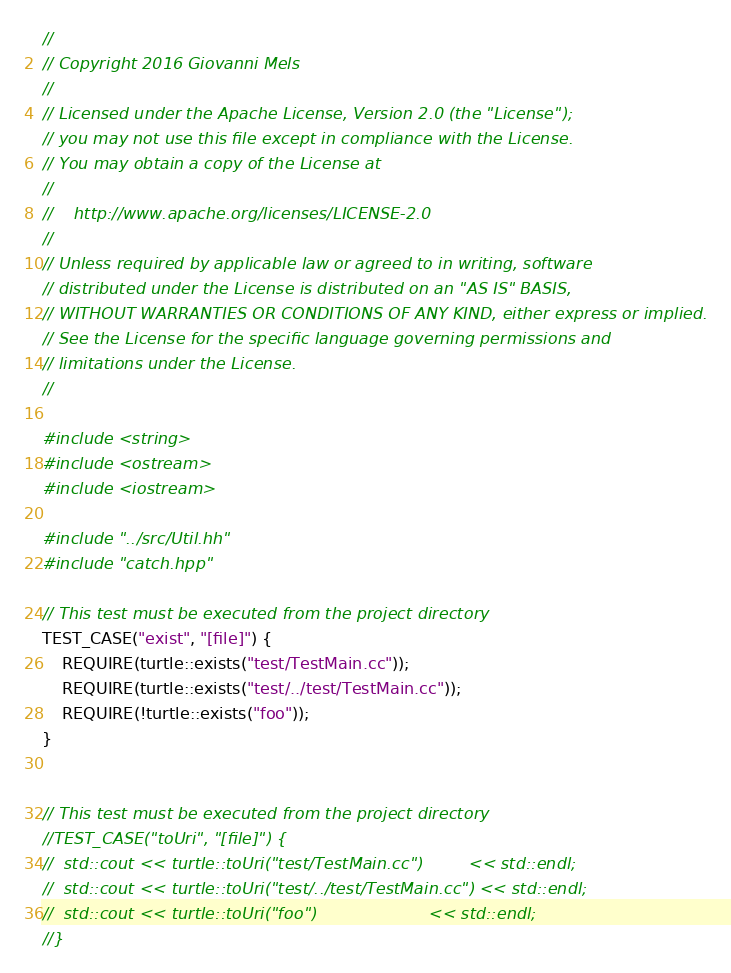Convert code to text. <code><loc_0><loc_0><loc_500><loc_500><_C++_>//
// Copyright 2016 Giovanni Mels
// 
// Licensed under the Apache License, Version 2.0 (the "License");
// you may not use this file except in compliance with the License.
// You may obtain a copy of the License at
//
//    http://www.apache.org/licenses/LICENSE-2.0
//
// Unless required by applicable law or agreed to in writing, software
// distributed under the License is distributed on an "AS IS" BASIS,
// WITHOUT WARRANTIES OR CONDITIONS OF ANY KIND, either express or implied.
// See the License for the specific language governing permissions and
// limitations under the License.
//

#include <string>
#include <ostream>
#include <iostream>

#include "../src/Util.hh"
#include "catch.hpp"

// This test must be executed from the project directory
TEST_CASE("exist", "[file]") {
	REQUIRE(turtle::exists("test/TestMain.cc"));
	REQUIRE(turtle::exists("test/../test/TestMain.cc"));
	REQUIRE(!turtle::exists("foo"));
}


// This test must be executed from the project directory
//TEST_CASE("toUri", "[file]") {
//	std::cout << turtle::toUri("test/TestMain.cc")         << std::endl;
//	std::cout << turtle::toUri("test/../test/TestMain.cc") << std::endl;
//	std::cout << turtle::toUri("foo")                      << std::endl;
//}

</code> 